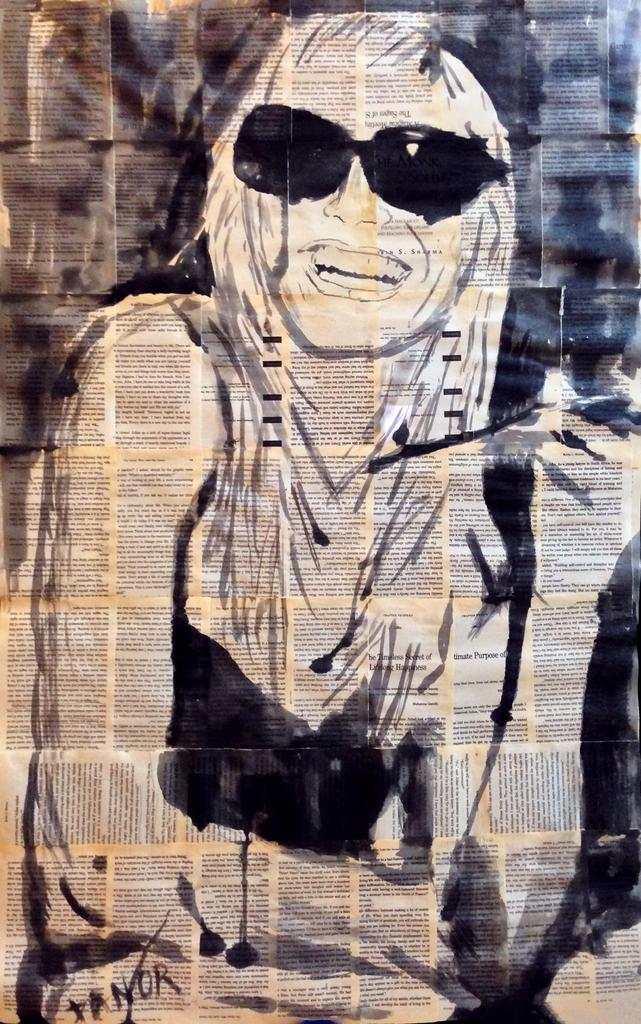What is present on the paper in the image? There is text and a sketch of a person on the paper. Can you describe the sketch on the paper? The sketch on the paper is of a person. What is the primary purpose of the paper in the image? The paper appears to be used for writing and drawing. What type of cable is connected to the person's coat in the image? There is no cable or coat present in the image; it only features a paper with text and a sketch of a person. 